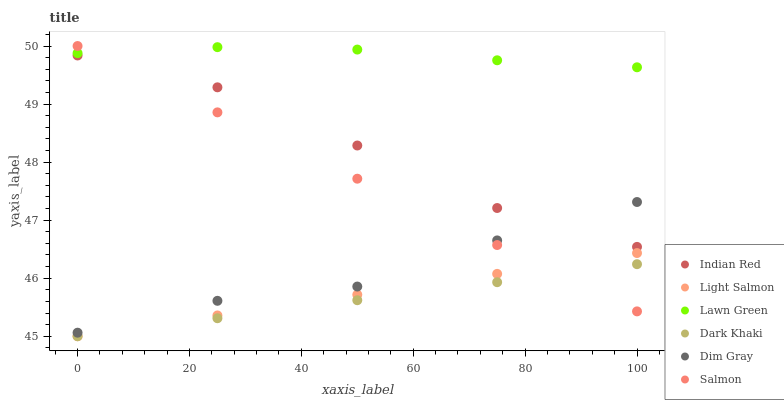Does Dark Khaki have the minimum area under the curve?
Answer yes or no. Yes. Does Lawn Green have the maximum area under the curve?
Answer yes or no. Yes. Does Light Salmon have the minimum area under the curve?
Answer yes or no. No. Does Light Salmon have the maximum area under the curve?
Answer yes or no. No. Is Dark Khaki the smoothest?
Answer yes or no. Yes. Is Dim Gray the roughest?
Answer yes or no. Yes. Is Light Salmon the smoothest?
Answer yes or no. No. Is Light Salmon the roughest?
Answer yes or no. No. Does Light Salmon have the lowest value?
Answer yes or no. Yes. Does Dim Gray have the lowest value?
Answer yes or no. No. Does Salmon have the highest value?
Answer yes or no. Yes. Does Light Salmon have the highest value?
Answer yes or no. No. Is Dim Gray less than Lawn Green?
Answer yes or no. Yes. Is Indian Red greater than Dark Khaki?
Answer yes or no. Yes. Does Dim Gray intersect Salmon?
Answer yes or no. Yes. Is Dim Gray less than Salmon?
Answer yes or no. No. Is Dim Gray greater than Salmon?
Answer yes or no. No. Does Dim Gray intersect Lawn Green?
Answer yes or no. No. 